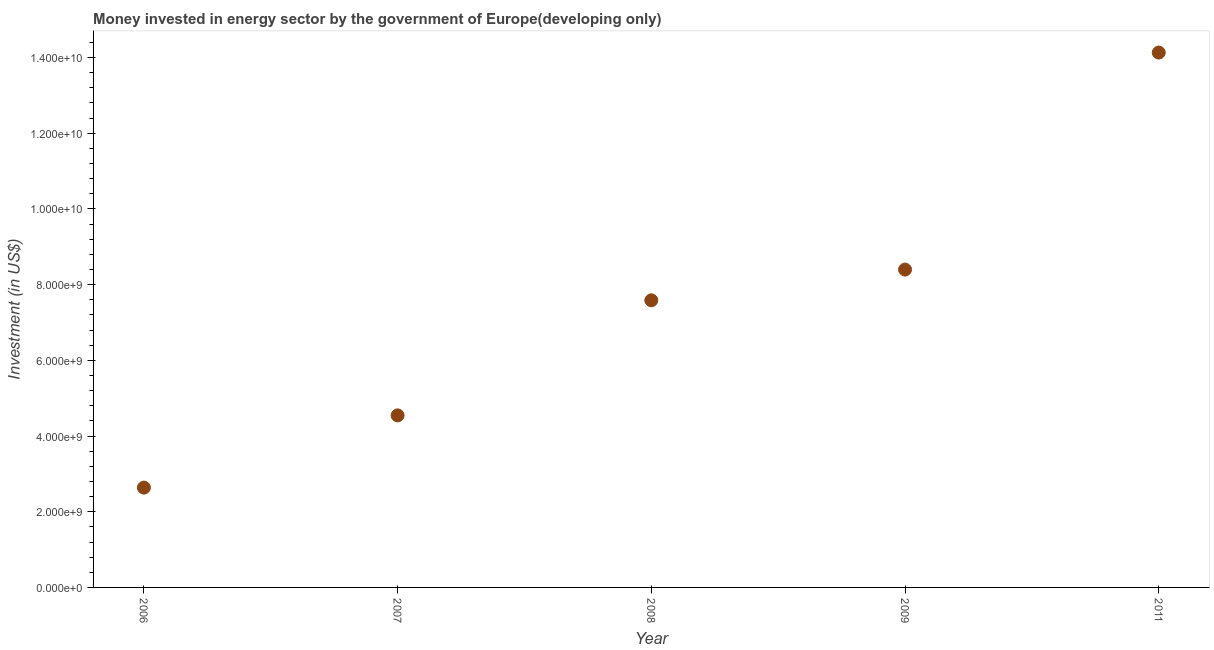What is the investment in energy in 2009?
Make the answer very short. 8.40e+09. Across all years, what is the maximum investment in energy?
Provide a short and direct response. 1.41e+1. Across all years, what is the minimum investment in energy?
Ensure brevity in your answer.  2.64e+09. What is the sum of the investment in energy?
Your answer should be compact. 3.73e+1. What is the difference between the investment in energy in 2009 and 2011?
Provide a succinct answer. -5.73e+09. What is the average investment in energy per year?
Make the answer very short. 7.46e+09. What is the median investment in energy?
Keep it short and to the point. 7.59e+09. In how many years, is the investment in energy greater than 12800000000 US$?
Give a very brief answer. 1. What is the ratio of the investment in energy in 2006 to that in 2007?
Provide a short and direct response. 0.58. Is the investment in energy in 2006 less than that in 2011?
Give a very brief answer. Yes. Is the difference between the investment in energy in 2006 and 2009 greater than the difference between any two years?
Your response must be concise. No. What is the difference between the highest and the second highest investment in energy?
Offer a very short reply. 5.73e+09. What is the difference between the highest and the lowest investment in energy?
Provide a short and direct response. 1.15e+1. Does the investment in energy monotonically increase over the years?
Ensure brevity in your answer.  Yes. What is the difference between two consecutive major ticks on the Y-axis?
Keep it short and to the point. 2.00e+09. Are the values on the major ticks of Y-axis written in scientific E-notation?
Your response must be concise. Yes. Does the graph contain any zero values?
Your answer should be very brief. No. Does the graph contain grids?
Offer a very short reply. No. What is the title of the graph?
Provide a short and direct response. Money invested in energy sector by the government of Europe(developing only). What is the label or title of the X-axis?
Keep it short and to the point. Year. What is the label or title of the Y-axis?
Make the answer very short. Investment (in US$). What is the Investment (in US$) in 2006?
Provide a short and direct response. 2.64e+09. What is the Investment (in US$) in 2007?
Ensure brevity in your answer.  4.55e+09. What is the Investment (in US$) in 2008?
Your answer should be compact. 7.59e+09. What is the Investment (in US$) in 2009?
Give a very brief answer. 8.40e+09. What is the Investment (in US$) in 2011?
Ensure brevity in your answer.  1.41e+1. What is the difference between the Investment (in US$) in 2006 and 2007?
Your answer should be very brief. -1.91e+09. What is the difference between the Investment (in US$) in 2006 and 2008?
Make the answer very short. -4.95e+09. What is the difference between the Investment (in US$) in 2006 and 2009?
Give a very brief answer. -5.76e+09. What is the difference between the Investment (in US$) in 2006 and 2011?
Keep it short and to the point. -1.15e+1. What is the difference between the Investment (in US$) in 2007 and 2008?
Keep it short and to the point. -3.04e+09. What is the difference between the Investment (in US$) in 2007 and 2009?
Provide a succinct answer. -3.85e+09. What is the difference between the Investment (in US$) in 2007 and 2011?
Give a very brief answer. -9.58e+09. What is the difference between the Investment (in US$) in 2008 and 2009?
Provide a short and direct response. -8.12e+08. What is the difference between the Investment (in US$) in 2008 and 2011?
Ensure brevity in your answer.  -6.54e+09. What is the difference between the Investment (in US$) in 2009 and 2011?
Offer a very short reply. -5.73e+09. What is the ratio of the Investment (in US$) in 2006 to that in 2007?
Provide a short and direct response. 0.58. What is the ratio of the Investment (in US$) in 2006 to that in 2008?
Your answer should be compact. 0.35. What is the ratio of the Investment (in US$) in 2006 to that in 2009?
Provide a succinct answer. 0.31. What is the ratio of the Investment (in US$) in 2006 to that in 2011?
Your answer should be compact. 0.19. What is the ratio of the Investment (in US$) in 2007 to that in 2008?
Your answer should be compact. 0.6. What is the ratio of the Investment (in US$) in 2007 to that in 2009?
Provide a succinct answer. 0.54. What is the ratio of the Investment (in US$) in 2007 to that in 2011?
Provide a short and direct response. 0.32. What is the ratio of the Investment (in US$) in 2008 to that in 2009?
Your answer should be compact. 0.9. What is the ratio of the Investment (in US$) in 2008 to that in 2011?
Ensure brevity in your answer.  0.54. What is the ratio of the Investment (in US$) in 2009 to that in 2011?
Give a very brief answer. 0.59. 